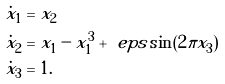Convert formula to latex. <formula><loc_0><loc_0><loc_500><loc_500>\dot { x } _ { 1 } & = x _ { 2 } \\ \dot { x } _ { 2 } & = x _ { 1 } - x _ { 1 } ^ { 3 } + \ e p s \sin ( 2 \pi x _ { 3 } ) \\ \dot { x } _ { 3 } & = 1 .</formula> 